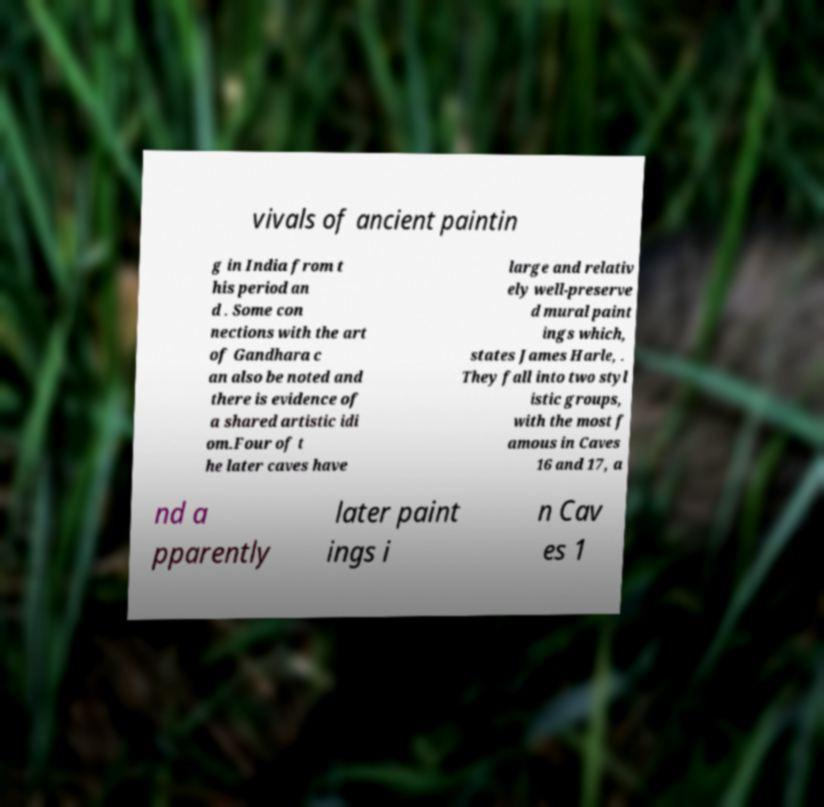I need the written content from this picture converted into text. Can you do that? vivals of ancient paintin g in India from t his period an d . Some con nections with the art of Gandhara c an also be noted and there is evidence of a shared artistic idi om.Four of t he later caves have large and relativ ely well-preserve d mural paint ings which, states James Harle, . They fall into two styl istic groups, with the most f amous in Caves 16 and 17, a nd a pparently later paint ings i n Cav es 1 